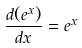<formula> <loc_0><loc_0><loc_500><loc_500>\frac { d ( e ^ { x } ) } { d x } = e ^ { x }</formula> 